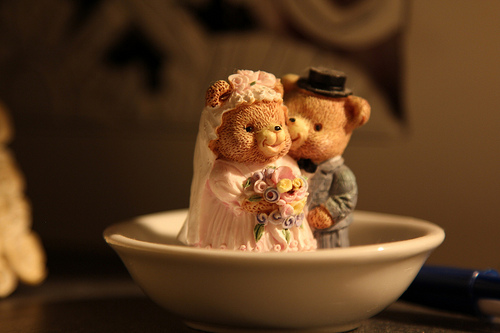<image>
Is there a lip in the lip? No. The lip is not contained within the lip. These objects have a different spatial relationship. 